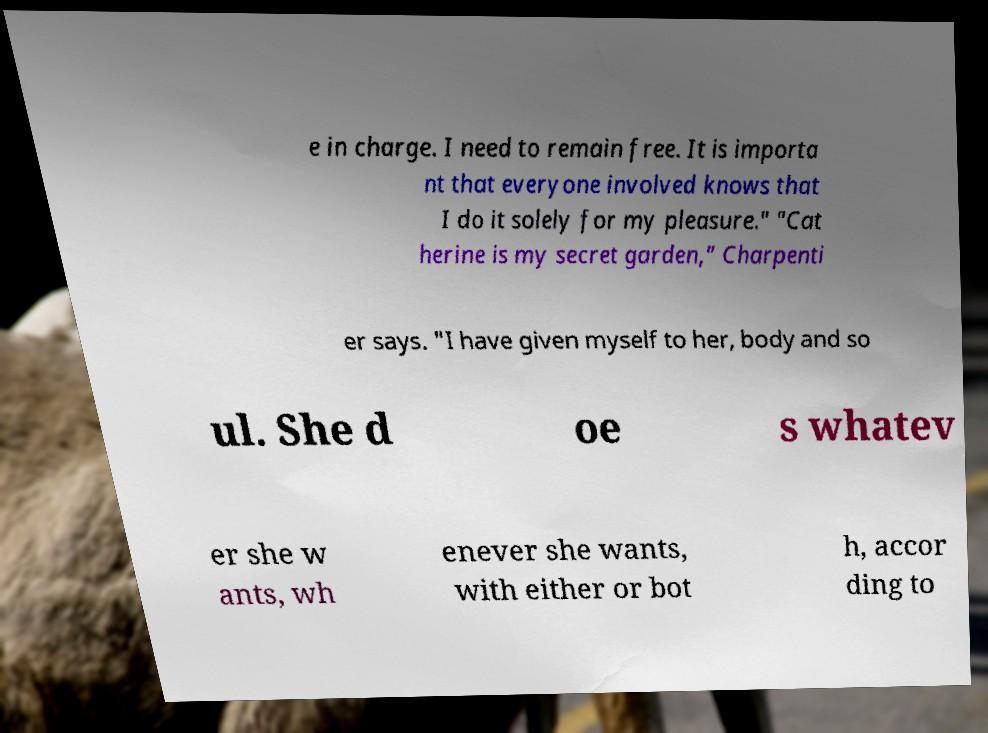I need the written content from this picture converted into text. Can you do that? e in charge. I need to remain free. It is importa nt that everyone involved knows that I do it solely for my pleasure." "Cat herine is my secret garden,” Charpenti er says. "I have given myself to her, body and so ul. She d oe s whatev er she w ants, wh enever she wants, with either or bot h, accor ding to 